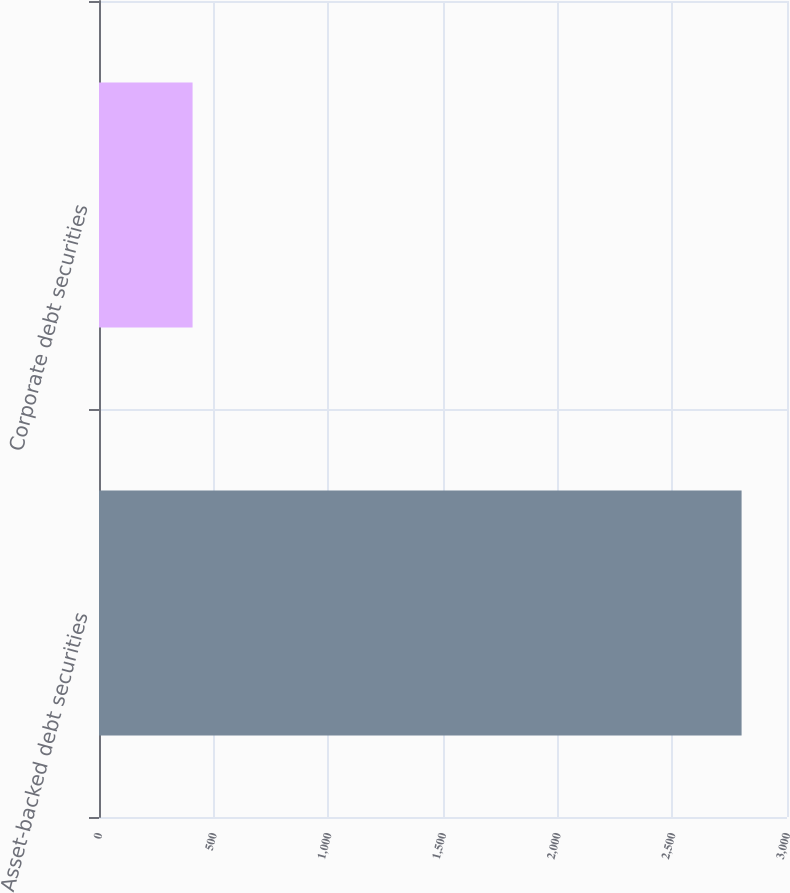Convert chart. <chart><loc_0><loc_0><loc_500><loc_500><bar_chart><fcel>Asset-backed debt securities<fcel>Corporate debt securities<nl><fcel>2802<fcel>408<nl></chart> 